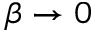Convert formula to latex. <formula><loc_0><loc_0><loc_500><loc_500>\beta \to 0</formula> 